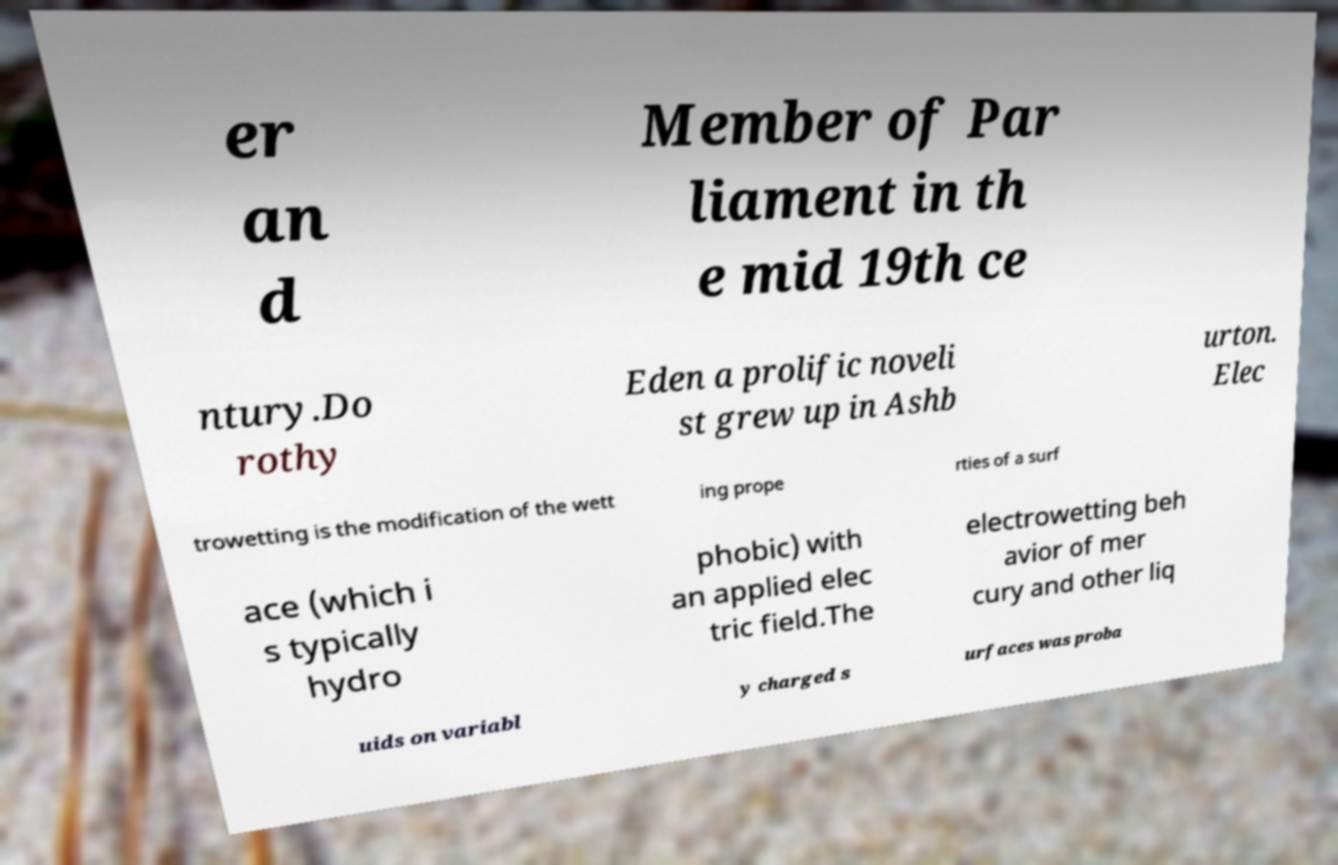For documentation purposes, I need the text within this image transcribed. Could you provide that? er an d Member of Par liament in th e mid 19th ce ntury.Do rothy Eden a prolific noveli st grew up in Ashb urton. Elec trowetting is the modification of the wett ing prope rties of a surf ace (which i s typically hydro phobic) with an applied elec tric field.The electrowetting beh avior of mer cury and other liq uids on variabl y charged s urfaces was proba 